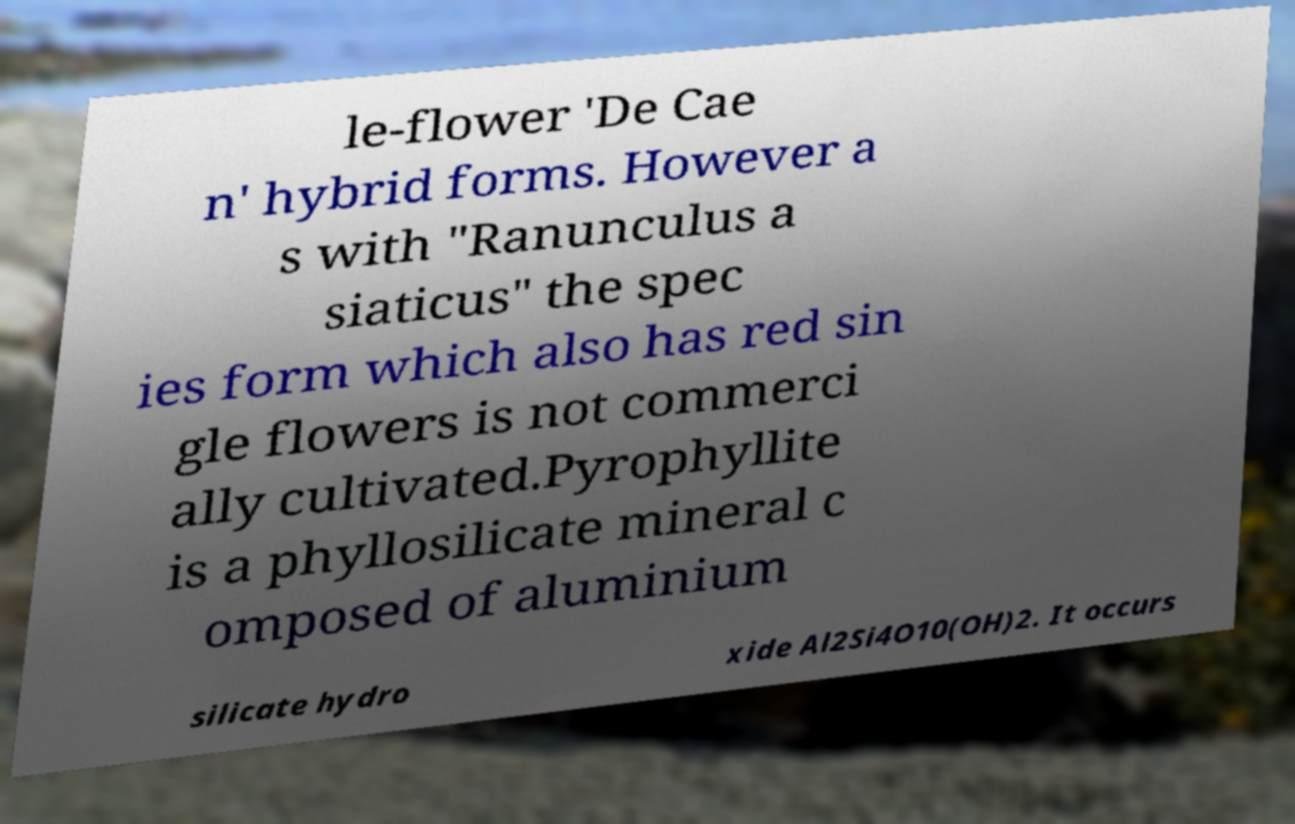Can you accurately transcribe the text from the provided image for me? le-flower 'De Cae n' hybrid forms. However a s with "Ranunculus a siaticus" the spec ies form which also has red sin gle flowers is not commerci ally cultivated.Pyrophyllite is a phyllosilicate mineral c omposed of aluminium silicate hydro xide Al2Si4O10(OH)2. It occurs 